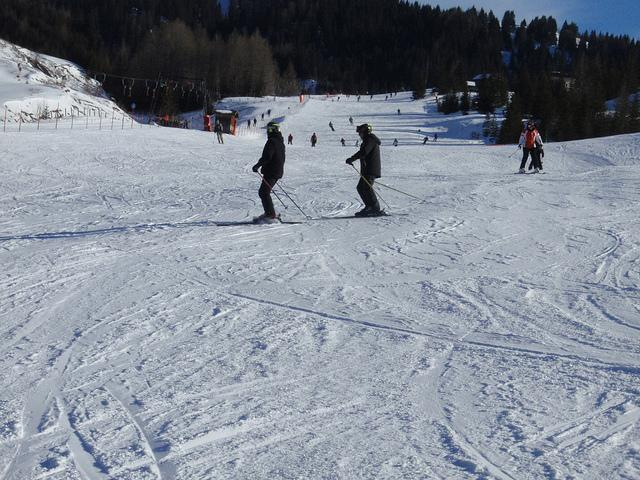Where can you most likely catch a ride nearby? Please explain your reasoning. ski lift. This is a ski resort and a ski lift is a typical type of transportation at a ski resort. 